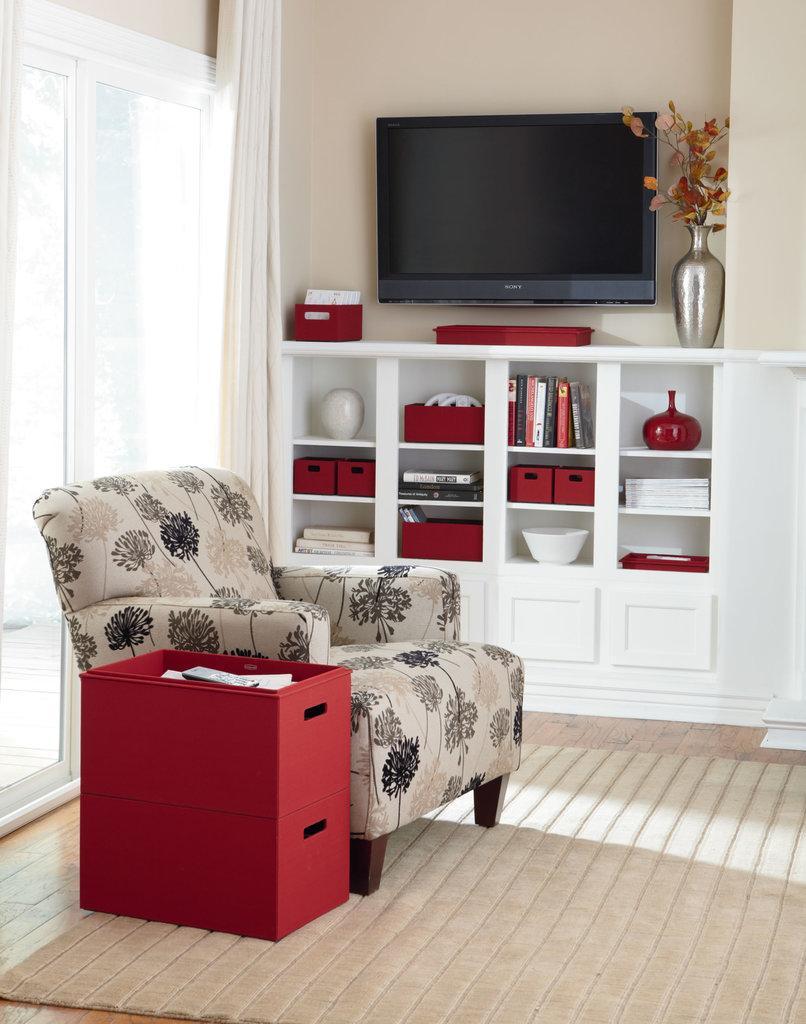Please provide a concise description of this image. In this image we can see a sofa with some design printed on it and beside the sofa we can see a desk which is red in color and there is a remote in it at the back of the sofa we have a long glass window where there is also a white color curtain and beside the curtain we have a wall where a TV is fitted to the wall and below the TV we have a shelf where we can see some objects are placed in it like books and all and we also have a flower pot over here which has some flowers in it. 